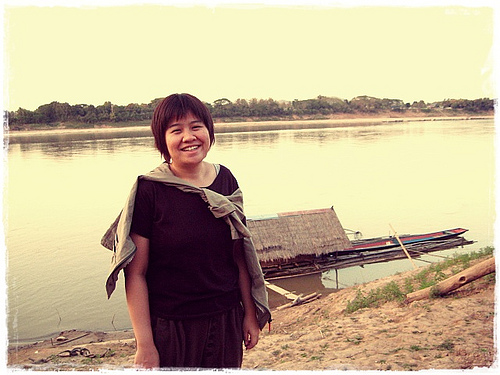<image>
Is there a girl behind the water? No. The girl is not behind the water. From this viewpoint, the girl appears to be positioned elsewhere in the scene. 